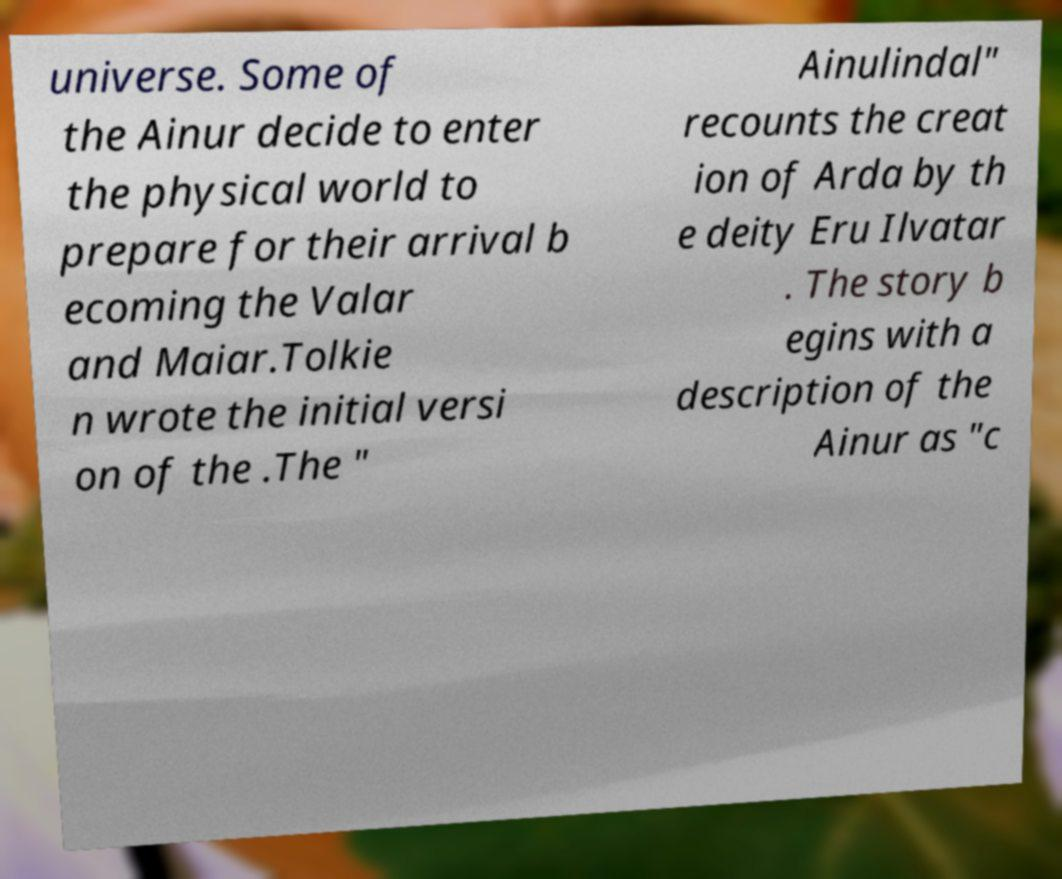Can you accurately transcribe the text from the provided image for me? universe. Some of the Ainur decide to enter the physical world to prepare for their arrival b ecoming the Valar and Maiar.Tolkie n wrote the initial versi on of the .The " Ainulindal" recounts the creat ion of Arda by th e deity Eru Ilvatar . The story b egins with a description of the Ainur as "c 